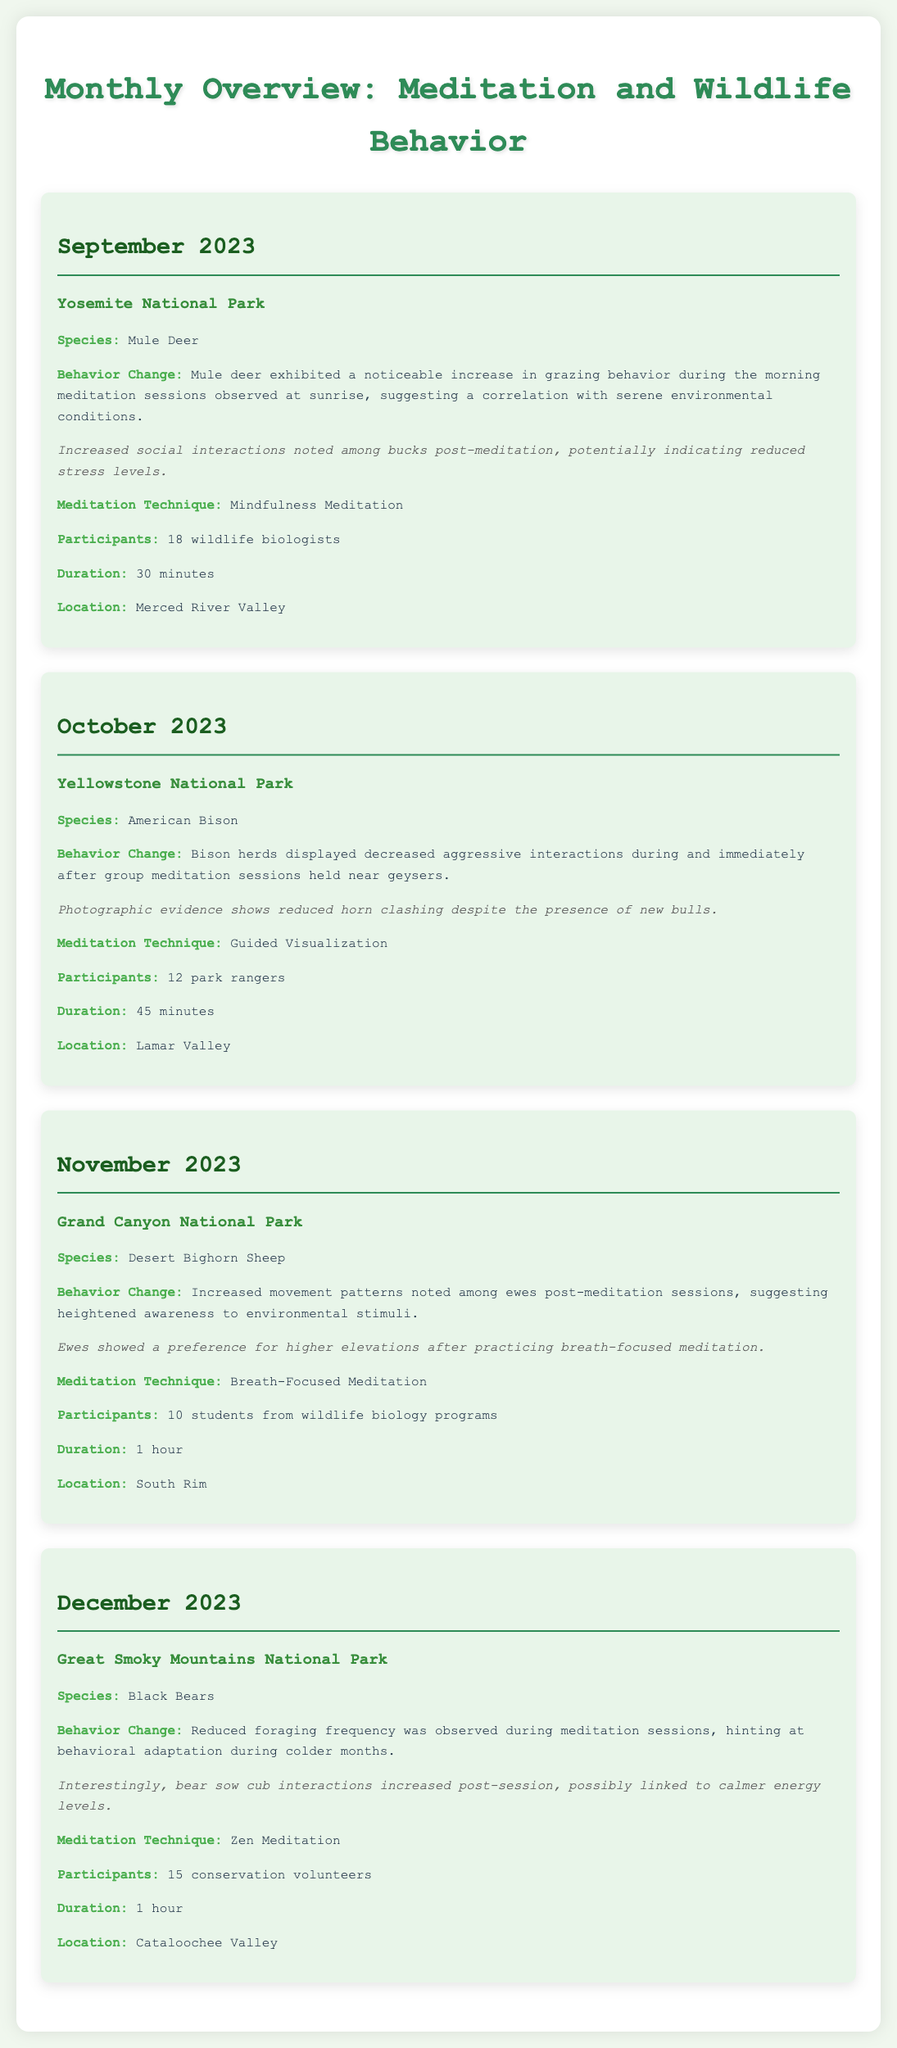What species was observed in Yosemite National Park? The document lists species observed in each park, stating Mule Deer for Yosemite National Park.
Answer: Mule Deer What meditation technique was used during the observation of Black Bears? The document specifies the meditation technique used for each species, stating Zen Meditation for Black Bears.
Answer: Zen Meditation How many wildlife biologists participated in the mindfulness meditation session in September? The participant number for each meditation session is detailed, with 18 wildlife biologists noted for the session in September.
Answer: 18 What behavior change was noted in the American Bison during meditation sessions? The document describes behavior changes per species, revealing decreased aggressive interactions for American Bison during sessions.
Answer: Decreased aggressive interactions Which national park had Desert Bighorn Sheep as the observed species, and in which month? The document provides observations conducted in national parks, indicating Grand Canyon National Park in November for Desert Bighorn Sheep.
Answer: Grand Canyon National Park, November What was the duration of the meditation sessions for the Desert Bighorn Sheep? The duration of each meditation session is listed in the document, stating 1 hour for Desert Bighorn Sheep.
Answer: 1 hour What notable change was observed in the interactions among the black bear cubs after meditation? The observations include notes on animal behaviors; in this case, increased interactions among bear cubs were noted post-session.
Answer: Increased interactions How many participants were involved in the group meditation for the American Bison? The document gives participant details for each session, stating 12 park rangers were involved for American Bison.
Answer: 12 Which month included mindfulness meditation sessions at Yosemite National Park? The document lists the dates for each park and the corresponding meditation techniques, noting mindfulness meditation took place in September.
Answer: September 